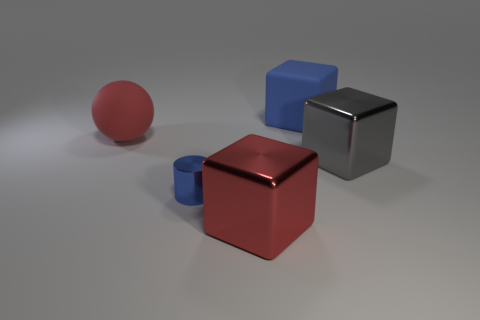Add 2 small things. How many objects exist? 7 Subtract all blocks. How many objects are left? 2 Add 4 red balls. How many red balls are left? 5 Add 3 large gray metallic objects. How many large gray metallic objects exist? 4 Subtract 0 purple balls. How many objects are left? 5 Subtract all large blue matte things. Subtract all gray shiny things. How many objects are left? 3 